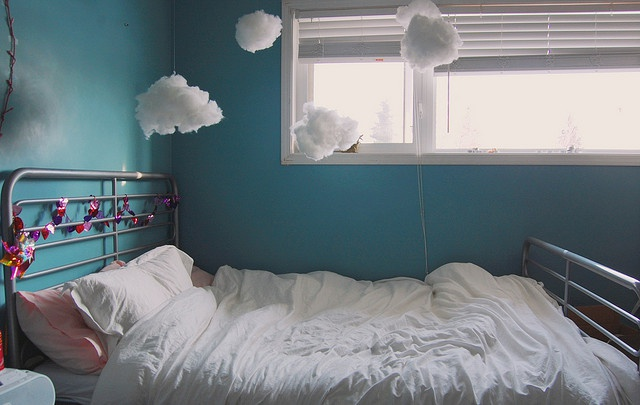Describe the objects in this image and their specific colors. I can see a bed in teal, darkgray, gray, and black tones in this image. 